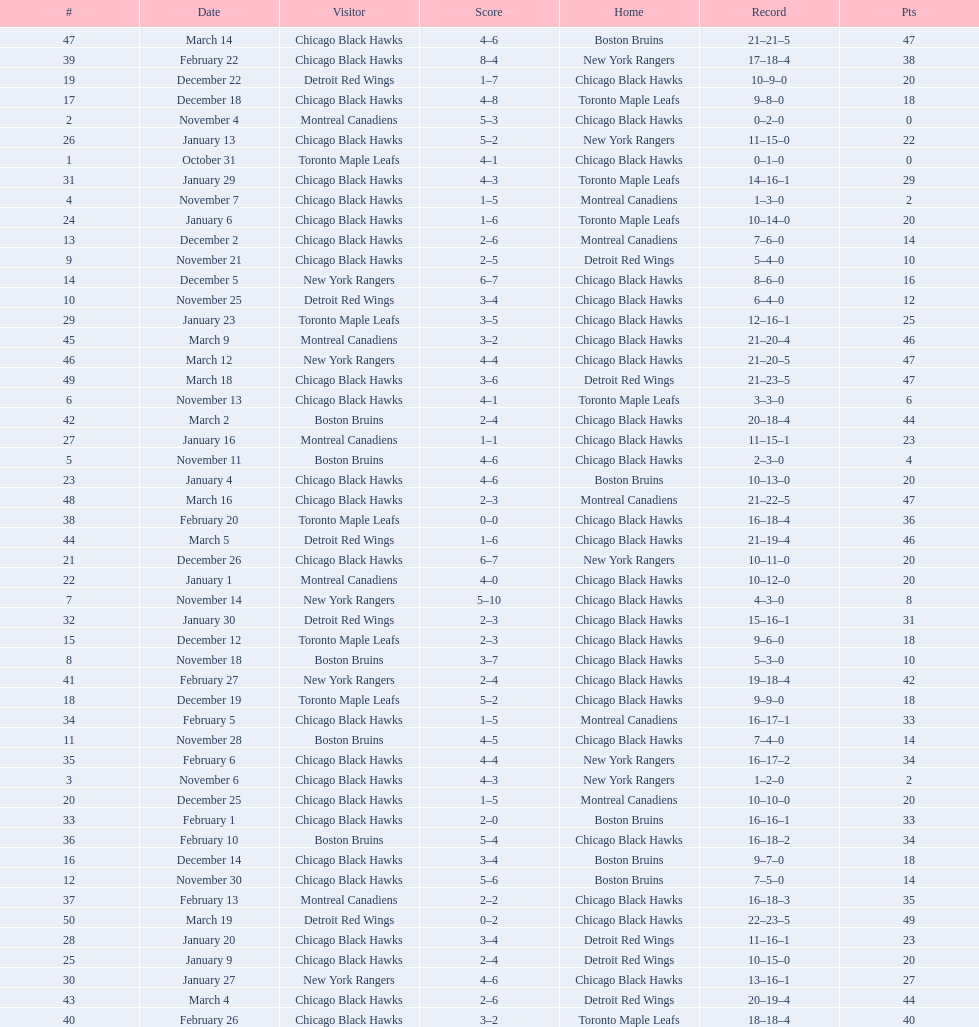How many total games did they win? 22. Could you parse the entire table as a dict? {'header': ['#', 'Date', 'Visitor', 'Score', 'Home', 'Record', 'Pts'], 'rows': [['47', 'March 14', 'Chicago Black Hawks', '4–6', 'Boston Bruins', '21–21–5', '47'], ['39', 'February 22', 'Chicago Black Hawks', '8–4', 'New York Rangers', '17–18–4', '38'], ['19', 'December 22', 'Detroit Red Wings', '1–7', 'Chicago Black Hawks', '10–9–0', '20'], ['17', 'December 18', 'Chicago Black Hawks', '4–8', 'Toronto Maple Leafs', '9–8–0', '18'], ['2', 'November 4', 'Montreal Canadiens', '5–3', 'Chicago Black Hawks', '0–2–0', '0'], ['26', 'January 13', 'Chicago Black Hawks', '5–2', 'New York Rangers', '11–15–0', '22'], ['1', 'October 31', 'Toronto Maple Leafs', '4–1', 'Chicago Black Hawks', '0–1–0', '0'], ['31', 'January 29', 'Chicago Black Hawks', '4–3', 'Toronto Maple Leafs', '14–16–1', '29'], ['4', 'November 7', 'Chicago Black Hawks', '1–5', 'Montreal Canadiens', '1–3–0', '2'], ['24', 'January 6', 'Chicago Black Hawks', '1–6', 'Toronto Maple Leafs', '10–14–0', '20'], ['13', 'December 2', 'Chicago Black Hawks', '2–6', 'Montreal Canadiens', '7–6–0', '14'], ['9', 'November 21', 'Chicago Black Hawks', '2–5', 'Detroit Red Wings', '5–4–0', '10'], ['14', 'December 5', 'New York Rangers', '6–7', 'Chicago Black Hawks', '8–6–0', '16'], ['10', 'November 25', 'Detroit Red Wings', '3–4', 'Chicago Black Hawks', '6–4–0', '12'], ['29', 'January 23', 'Toronto Maple Leafs', '3–5', 'Chicago Black Hawks', '12–16–1', '25'], ['45', 'March 9', 'Montreal Canadiens', '3–2', 'Chicago Black Hawks', '21–20–4', '46'], ['46', 'March 12', 'New York Rangers', '4–4', 'Chicago Black Hawks', '21–20–5', '47'], ['49', 'March 18', 'Chicago Black Hawks', '3–6', 'Detroit Red Wings', '21–23–5', '47'], ['6', 'November 13', 'Chicago Black Hawks', '4–1', 'Toronto Maple Leafs', '3–3–0', '6'], ['42', 'March 2', 'Boston Bruins', '2–4', 'Chicago Black Hawks', '20–18–4', '44'], ['27', 'January 16', 'Montreal Canadiens', '1–1', 'Chicago Black Hawks', '11–15–1', '23'], ['5', 'November 11', 'Boston Bruins', '4–6', 'Chicago Black Hawks', '2–3–0', '4'], ['23', 'January 4', 'Chicago Black Hawks', '4–6', 'Boston Bruins', '10–13–0', '20'], ['48', 'March 16', 'Chicago Black Hawks', '2–3', 'Montreal Canadiens', '21–22–5', '47'], ['38', 'February 20', 'Toronto Maple Leafs', '0–0', 'Chicago Black Hawks', '16–18–4', '36'], ['44', 'March 5', 'Detroit Red Wings', '1–6', 'Chicago Black Hawks', '21–19–4', '46'], ['21', 'December 26', 'Chicago Black Hawks', '6–7', 'New York Rangers', '10–11–0', '20'], ['22', 'January 1', 'Montreal Canadiens', '4–0', 'Chicago Black Hawks', '10–12–0', '20'], ['7', 'November 14', 'New York Rangers', '5–10', 'Chicago Black Hawks', '4–3–0', '8'], ['32', 'January 30', 'Detroit Red Wings', '2–3', 'Chicago Black Hawks', '15–16–1', '31'], ['15', 'December 12', 'Toronto Maple Leafs', '2–3', 'Chicago Black Hawks', '9–6–0', '18'], ['8', 'November 18', 'Boston Bruins', '3–7', 'Chicago Black Hawks', '5–3–0', '10'], ['41', 'February 27', 'New York Rangers', '2–4', 'Chicago Black Hawks', '19–18–4', '42'], ['18', 'December 19', 'Toronto Maple Leafs', '5–2', 'Chicago Black Hawks', '9–9–0', '18'], ['34', 'February 5', 'Chicago Black Hawks', '1–5', 'Montreal Canadiens', '16–17–1', '33'], ['11', 'November 28', 'Boston Bruins', '4–5', 'Chicago Black Hawks', '7–4–0', '14'], ['35', 'February 6', 'Chicago Black Hawks', '4–4', 'New York Rangers', '16–17–2', '34'], ['3', 'November 6', 'Chicago Black Hawks', '4–3', 'New York Rangers', '1–2–0', '2'], ['20', 'December 25', 'Chicago Black Hawks', '1–5', 'Montreal Canadiens', '10–10–0', '20'], ['33', 'February 1', 'Chicago Black Hawks', '2–0', 'Boston Bruins', '16–16–1', '33'], ['36', 'February 10', 'Boston Bruins', '5–4', 'Chicago Black Hawks', '16–18–2', '34'], ['16', 'December 14', 'Chicago Black Hawks', '3–4', 'Boston Bruins', '9–7–0', '18'], ['12', 'November 30', 'Chicago Black Hawks', '5–6', 'Boston Bruins', '7–5–0', '14'], ['37', 'February 13', 'Montreal Canadiens', '2–2', 'Chicago Black Hawks', '16–18–3', '35'], ['50', 'March 19', 'Detroit Red Wings', '0–2', 'Chicago Black Hawks', '22–23–5', '49'], ['28', 'January 20', 'Chicago Black Hawks', '3–4', 'Detroit Red Wings', '11–16–1', '23'], ['25', 'January 9', 'Chicago Black Hawks', '2–4', 'Detroit Red Wings', '10–15–0', '20'], ['30', 'January 27', 'New York Rangers', '4–6', 'Chicago Black Hawks', '13–16–1', '27'], ['43', 'March 4', 'Chicago Black Hawks', '2–6', 'Detroit Red Wings', '20–19–4', '44'], ['40', 'February 26', 'Chicago Black Hawks', '3–2', 'Toronto Maple Leafs', '18–18–4', '40']]} 